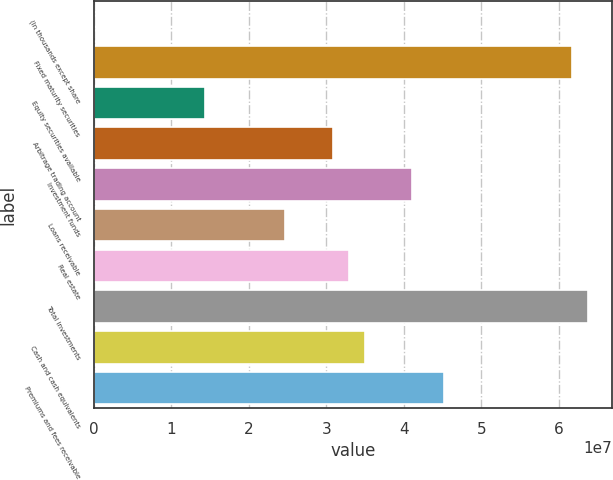Convert chart to OTSL. <chart><loc_0><loc_0><loc_500><loc_500><bar_chart><fcel>(In thousands except share<fcel>Fixed maturity securities<fcel>Equity securities available<fcel>Arbitrage trading account<fcel>Investment funds<fcel>Loans receivable<fcel>Real estate<fcel>Total investments<fcel>Cash and cash equivalents<fcel>Premiums and fees receivable<nl><fcel>2013<fcel>6.16514e+07<fcel>1.43869e+07<fcel>3.08267e+07<fcel>4.11016e+07<fcel>2.46618e+07<fcel>3.28817e+07<fcel>6.37063e+07<fcel>3.49366e+07<fcel>4.52115e+07<nl></chart> 